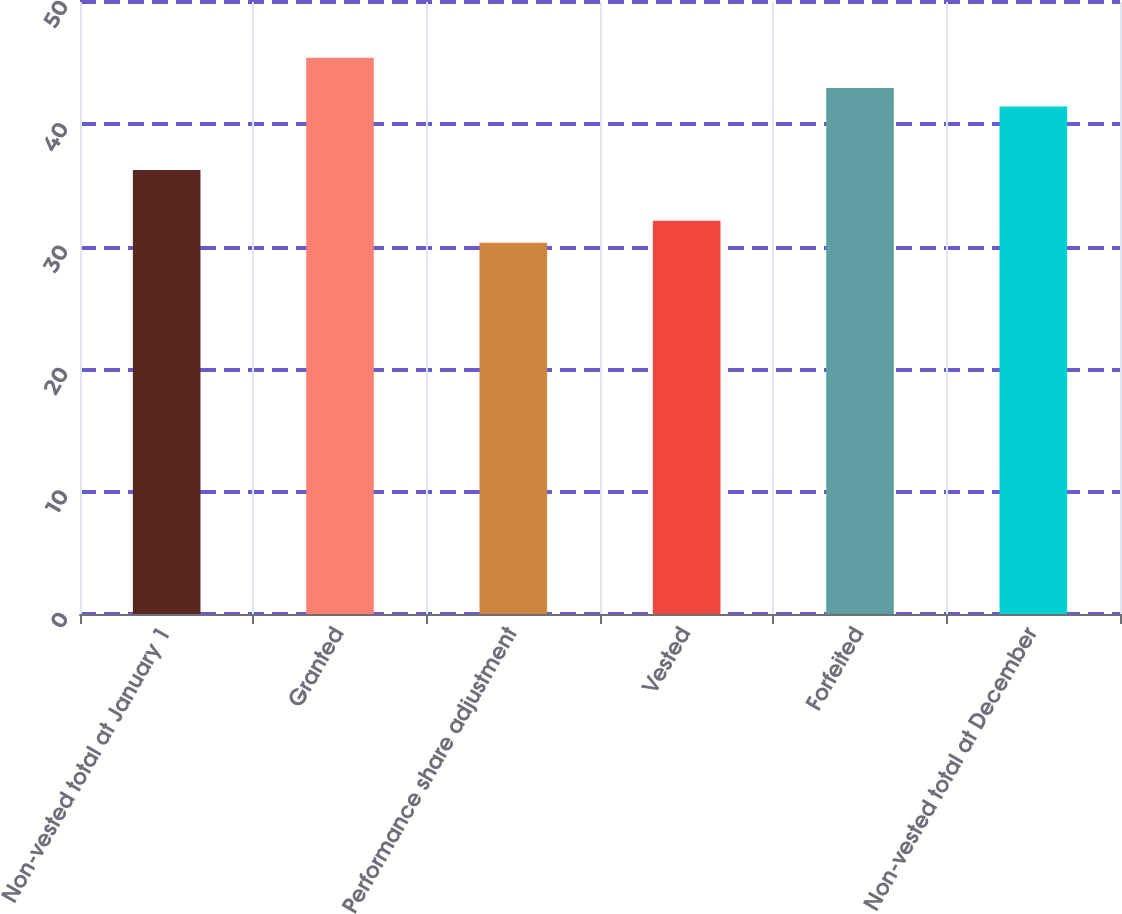Convert chart to OTSL. <chart><loc_0><loc_0><loc_500><loc_500><bar_chart><fcel>Non-vested total at January 1<fcel>Granted<fcel>Performance share adjustment<fcel>Vested<fcel>Forfeited<fcel>Non-vested total at December<nl><fcel>36.27<fcel>45.45<fcel>30.34<fcel>32.13<fcel>42.97<fcel>41.46<nl></chart> 